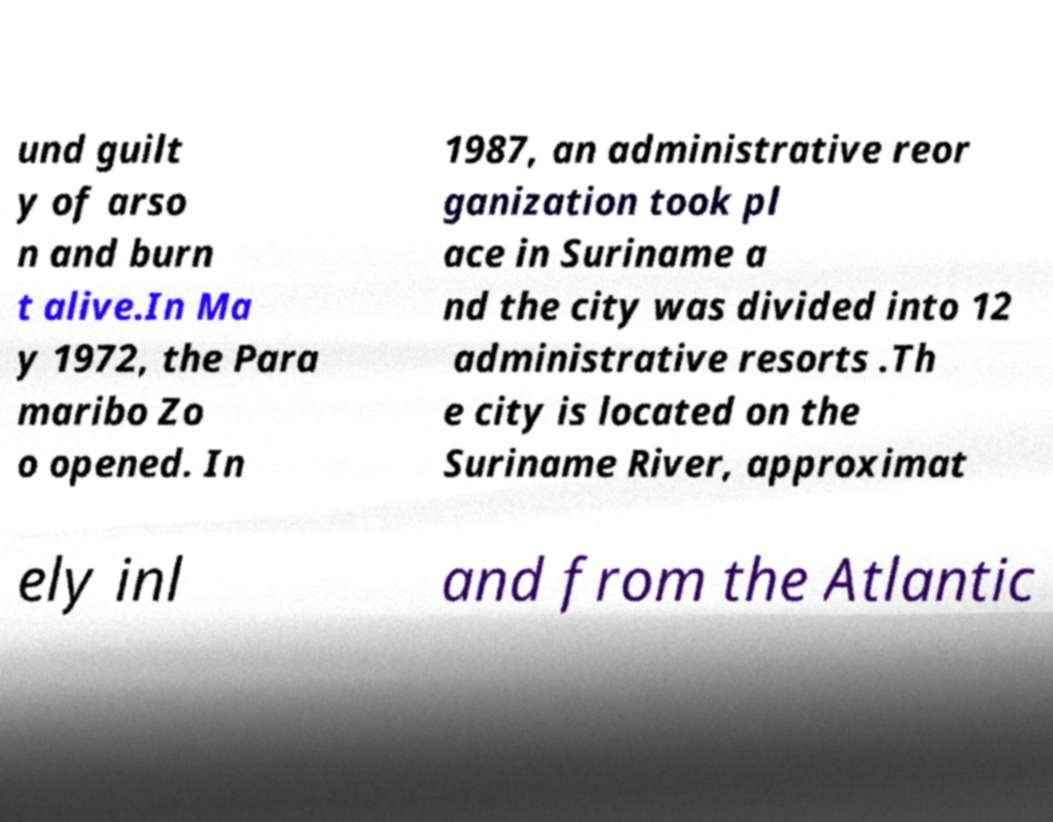Please identify and transcribe the text found in this image. und guilt y of arso n and burn t alive.In Ma y 1972, the Para maribo Zo o opened. In 1987, an administrative reor ganization took pl ace in Suriname a nd the city was divided into 12 administrative resorts .Th e city is located on the Suriname River, approximat ely inl and from the Atlantic 